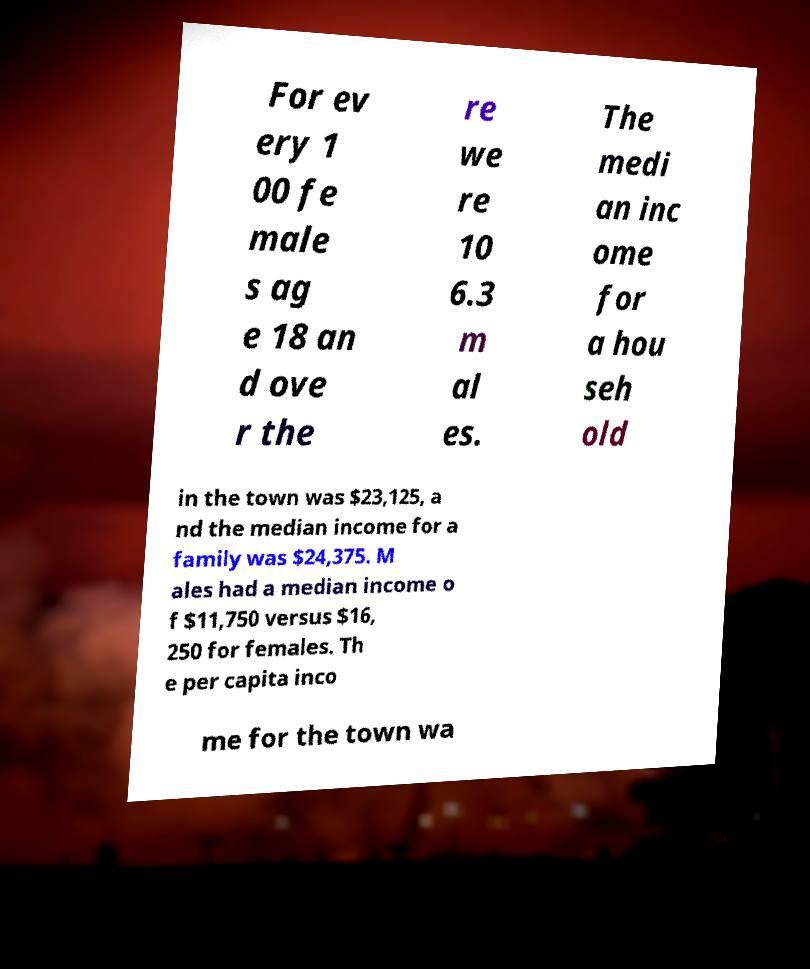Could you assist in decoding the text presented in this image and type it out clearly? For ev ery 1 00 fe male s ag e 18 an d ove r the re we re 10 6.3 m al es. The medi an inc ome for a hou seh old in the town was $23,125, a nd the median income for a family was $24,375. M ales had a median income o f $11,750 versus $16, 250 for females. Th e per capita inco me for the town wa 